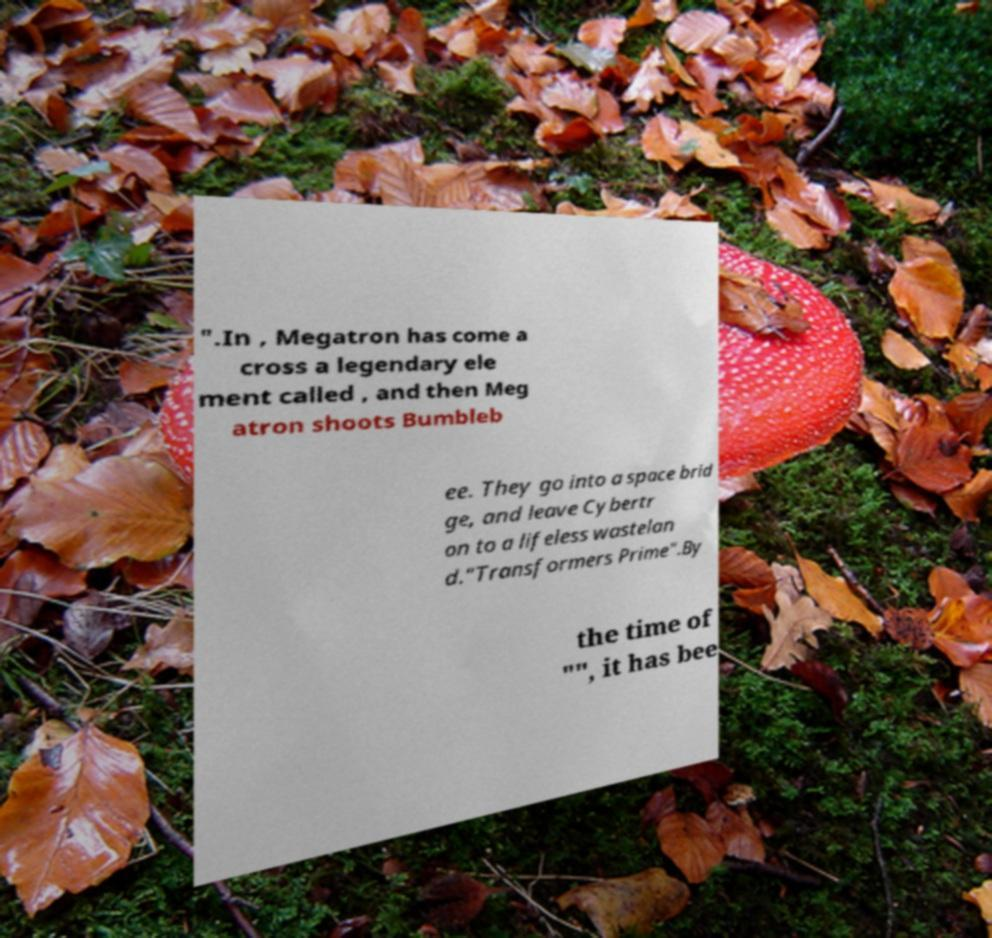What messages or text are displayed in this image? I need them in a readable, typed format. ".In , Megatron has come a cross a legendary ele ment called , and then Meg atron shoots Bumbleb ee. They go into a space brid ge, and leave Cybertr on to a lifeless wastelan d."Transformers Prime".By the time of "", it has bee 